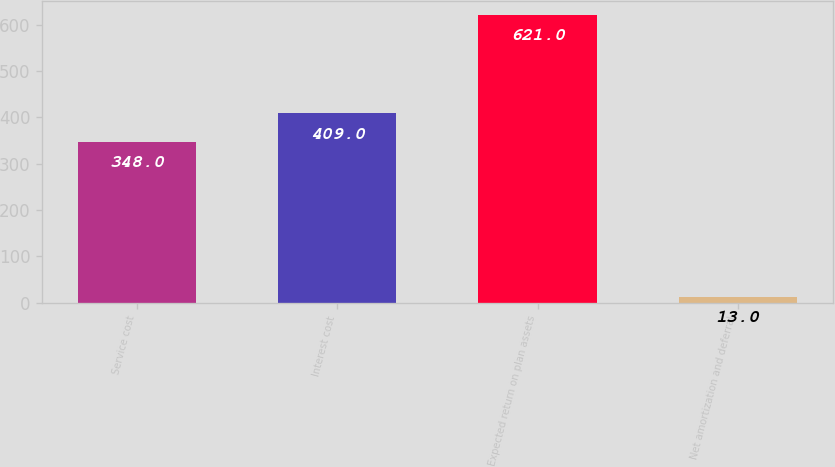Convert chart. <chart><loc_0><loc_0><loc_500><loc_500><bar_chart><fcel>Service cost<fcel>Interest cost<fcel>Expected return on plan assets<fcel>Net amortization and deferral<nl><fcel>348<fcel>409<fcel>621<fcel>13<nl></chart> 